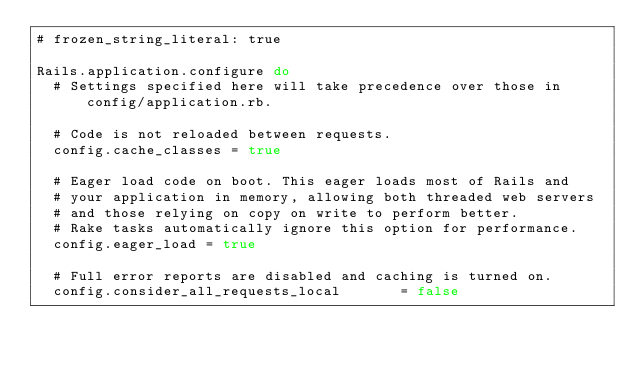<code> <loc_0><loc_0><loc_500><loc_500><_Ruby_># frozen_string_literal: true

Rails.application.configure do
  # Settings specified here will take precedence over those in config/application.rb.

  # Code is not reloaded between requests.
  config.cache_classes = true

  # Eager load code on boot. This eager loads most of Rails and
  # your application in memory, allowing both threaded web servers
  # and those relying on copy on write to perform better.
  # Rake tasks automatically ignore this option for performance.
  config.eager_load = true

  # Full error reports are disabled and caching is turned on.
  config.consider_all_requests_local       = false</code> 